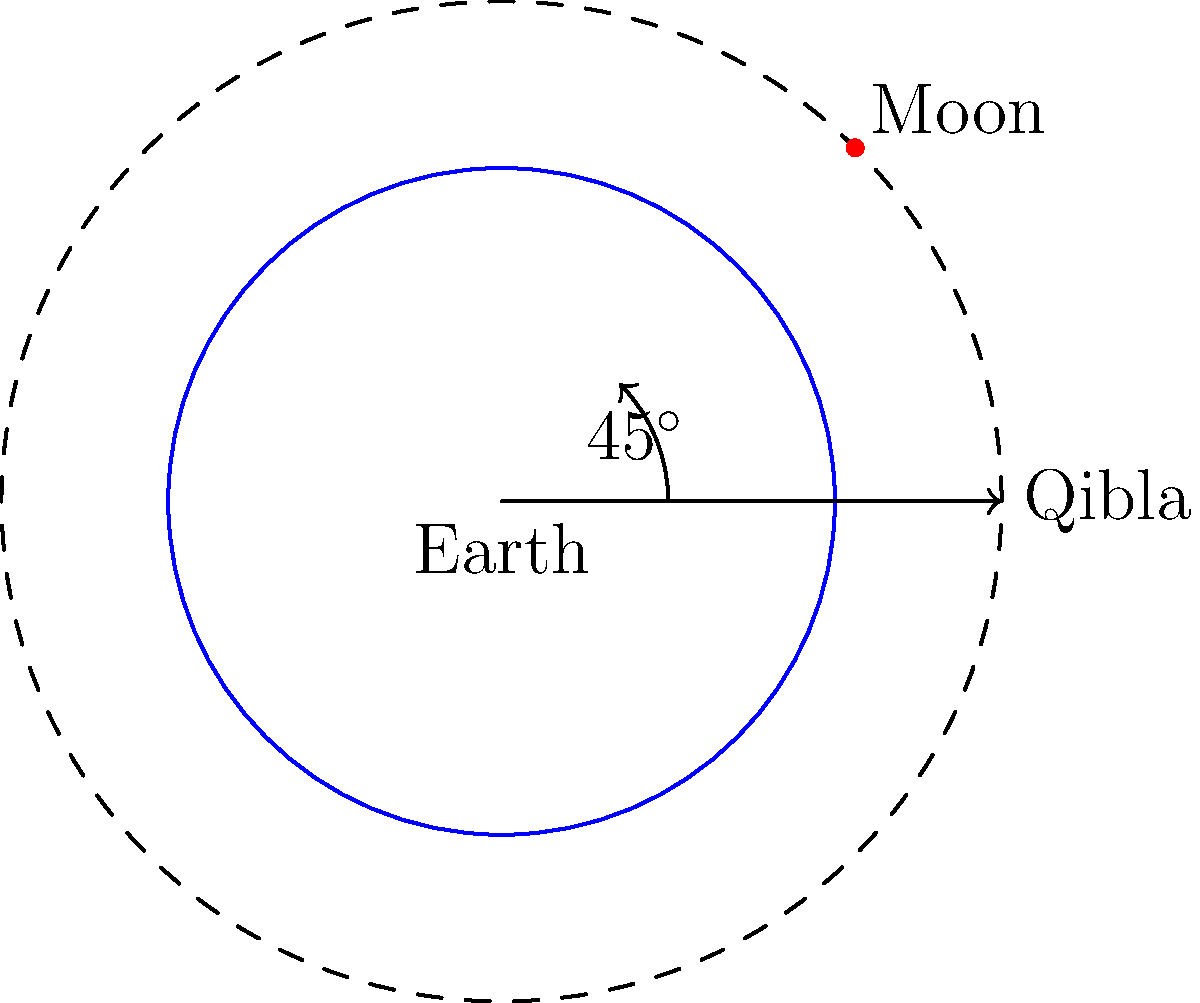During the Night of Power (Laylat al-Qadr) in 610 CE, when the first verses of the Qur'an were revealed to Prophet Muhammad (peace be upon him), the Moon was observed at a 45-degree angle from the Qibla direction. Given this celestial configuration, what was the approximate phase of the Moon on this significant night? To determine the Moon's phase based on its position relative to the Qibla direction, we need to follow these steps:

1. Understand the Moon's phases:
   - New Moon: 0° (aligned with the Sun)
   - First Quarter: 90° (right angle to the Sun)
   - Full Moon: 180° (opposite the Sun)
   - Last Quarter: 270° (right angle to the Sun)

2. Analyze the given information:
   - The Moon is at a 45-degree angle from the Qibla direction
   - The Qibla direction generally aligns with the direction of the Sun at noon

3. Interpret the Moon's position:
   - A 45-degree angle suggests the Moon is halfway between New Moon (0°) and First Quarter (90°)

4. Calculate the Moon's illumination:
   - At 45°, the Moon would be approximately 50% illuminated
   - This corresponds to a waxing crescent phase

5. Consider the significance:
   - The waxing crescent is often associated with new beginnings in Islamic tradition
   - This aligns well with the revelation of the first Qur'anic verses

Therefore, based on the celestial configuration described, the Moon would have been in its waxing crescent phase during the Night of Power in 610 CE.
Answer: Waxing crescent 